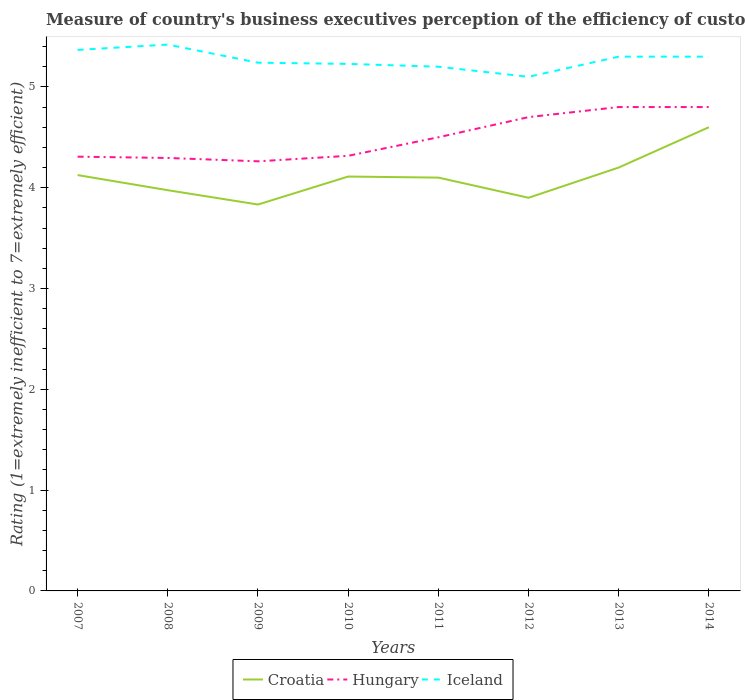How many different coloured lines are there?
Your answer should be compact. 3. Does the line corresponding to Croatia intersect with the line corresponding to Hungary?
Make the answer very short. No. Is the number of lines equal to the number of legend labels?
Offer a very short reply. Yes. Across all years, what is the maximum rating of the efficiency of customs procedure in Croatia?
Ensure brevity in your answer.  3.83. In which year was the rating of the efficiency of customs procedure in Croatia maximum?
Keep it short and to the point. 2009. What is the total rating of the efficiency of customs procedure in Hungary in the graph?
Provide a short and direct response. 0.03. What is the difference between the highest and the second highest rating of the efficiency of customs procedure in Iceland?
Your answer should be compact. 0.32. How many lines are there?
Ensure brevity in your answer.  3. Are the values on the major ticks of Y-axis written in scientific E-notation?
Offer a very short reply. No. Does the graph contain grids?
Make the answer very short. No. What is the title of the graph?
Keep it short and to the point. Measure of country's business executives perception of the efficiency of customs procedures. What is the label or title of the Y-axis?
Offer a terse response. Rating (1=extremely inefficient to 7=extremely efficient). What is the Rating (1=extremely inefficient to 7=extremely efficient) in Croatia in 2007?
Your response must be concise. 4.12. What is the Rating (1=extremely inefficient to 7=extremely efficient) of Hungary in 2007?
Ensure brevity in your answer.  4.31. What is the Rating (1=extremely inefficient to 7=extremely efficient) in Iceland in 2007?
Provide a succinct answer. 5.37. What is the Rating (1=extremely inefficient to 7=extremely efficient) of Croatia in 2008?
Your response must be concise. 3.98. What is the Rating (1=extremely inefficient to 7=extremely efficient) of Hungary in 2008?
Keep it short and to the point. 4.29. What is the Rating (1=extremely inefficient to 7=extremely efficient) in Iceland in 2008?
Your answer should be very brief. 5.42. What is the Rating (1=extremely inefficient to 7=extremely efficient) in Croatia in 2009?
Provide a short and direct response. 3.83. What is the Rating (1=extremely inefficient to 7=extremely efficient) of Hungary in 2009?
Provide a succinct answer. 4.26. What is the Rating (1=extremely inefficient to 7=extremely efficient) of Iceland in 2009?
Provide a succinct answer. 5.24. What is the Rating (1=extremely inefficient to 7=extremely efficient) of Croatia in 2010?
Provide a succinct answer. 4.11. What is the Rating (1=extremely inefficient to 7=extremely efficient) of Hungary in 2010?
Give a very brief answer. 4.32. What is the Rating (1=extremely inefficient to 7=extremely efficient) in Iceland in 2010?
Make the answer very short. 5.23. What is the Rating (1=extremely inefficient to 7=extremely efficient) of Croatia in 2011?
Your response must be concise. 4.1. What is the Rating (1=extremely inefficient to 7=extremely efficient) of Iceland in 2011?
Provide a succinct answer. 5.2. What is the Rating (1=extremely inefficient to 7=extremely efficient) of Croatia in 2012?
Provide a short and direct response. 3.9. What is the Rating (1=extremely inefficient to 7=extremely efficient) in Croatia in 2013?
Your answer should be very brief. 4.2. What is the Rating (1=extremely inefficient to 7=extremely efficient) of Croatia in 2014?
Provide a short and direct response. 4.6. What is the Rating (1=extremely inefficient to 7=extremely efficient) of Hungary in 2014?
Give a very brief answer. 4.8. Across all years, what is the maximum Rating (1=extremely inefficient to 7=extremely efficient) in Croatia?
Offer a terse response. 4.6. Across all years, what is the maximum Rating (1=extremely inefficient to 7=extremely efficient) in Iceland?
Ensure brevity in your answer.  5.42. Across all years, what is the minimum Rating (1=extremely inefficient to 7=extremely efficient) of Croatia?
Ensure brevity in your answer.  3.83. Across all years, what is the minimum Rating (1=extremely inefficient to 7=extremely efficient) in Hungary?
Provide a succinct answer. 4.26. Across all years, what is the minimum Rating (1=extremely inefficient to 7=extremely efficient) in Iceland?
Give a very brief answer. 5.1. What is the total Rating (1=extremely inefficient to 7=extremely efficient) of Croatia in the graph?
Your answer should be very brief. 32.84. What is the total Rating (1=extremely inefficient to 7=extremely efficient) of Hungary in the graph?
Offer a very short reply. 35.98. What is the total Rating (1=extremely inefficient to 7=extremely efficient) of Iceland in the graph?
Your response must be concise. 42.15. What is the difference between the Rating (1=extremely inefficient to 7=extremely efficient) in Hungary in 2007 and that in 2008?
Your response must be concise. 0.01. What is the difference between the Rating (1=extremely inefficient to 7=extremely efficient) in Iceland in 2007 and that in 2008?
Provide a short and direct response. -0.05. What is the difference between the Rating (1=extremely inefficient to 7=extremely efficient) in Croatia in 2007 and that in 2009?
Offer a very short reply. 0.29. What is the difference between the Rating (1=extremely inefficient to 7=extremely efficient) in Hungary in 2007 and that in 2009?
Your answer should be very brief. 0.05. What is the difference between the Rating (1=extremely inefficient to 7=extremely efficient) of Iceland in 2007 and that in 2009?
Keep it short and to the point. 0.13. What is the difference between the Rating (1=extremely inefficient to 7=extremely efficient) of Croatia in 2007 and that in 2010?
Keep it short and to the point. 0.01. What is the difference between the Rating (1=extremely inefficient to 7=extremely efficient) in Hungary in 2007 and that in 2010?
Your answer should be very brief. -0.01. What is the difference between the Rating (1=extremely inefficient to 7=extremely efficient) in Iceland in 2007 and that in 2010?
Give a very brief answer. 0.14. What is the difference between the Rating (1=extremely inefficient to 7=extremely efficient) of Croatia in 2007 and that in 2011?
Provide a short and direct response. 0.03. What is the difference between the Rating (1=extremely inefficient to 7=extremely efficient) of Hungary in 2007 and that in 2011?
Provide a short and direct response. -0.19. What is the difference between the Rating (1=extremely inefficient to 7=extremely efficient) of Croatia in 2007 and that in 2012?
Make the answer very short. 0.23. What is the difference between the Rating (1=extremely inefficient to 7=extremely efficient) of Hungary in 2007 and that in 2012?
Your response must be concise. -0.39. What is the difference between the Rating (1=extremely inefficient to 7=extremely efficient) of Iceland in 2007 and that in 2012?
Give a very brief answer. 0.27. What is the difference between the Rating (1=extremely inefficient to 7=extremely efficient) of Croatia in 2007 and that in 2013?
Keep it short and to the point. -0.07. What is the difference between the Rating (1=extremely inefficient to 7=extremely efficient) in Hungary in 2007 and that in 2013?
Your answer should be very brief. -0.49. What is the difference between the Rating (1=extremely inefficient to 7=extremely efficient) of Iceland in 2007 and that in 2013?
Offer a terse response. 0.07. What is the difference between the Rating (1=extremely inefficient to 7=extremely efficient) of Croatia in 2007 and that in 2014?
Provide a short and direct response. -0.47. What is the difference between the Rating (1=extremely inefficient to 7=extremely efficient) in Hungary in 2007 and that in 2014?
Offer a terse response. -0.49. What is the difference between the Rating (1=extremely inefficient to 7=extremely efficient) in Iceland in 2007 and that in 2014?
Provide a succinct answer. 0.07. What is the difference between the Rating (1=extremely inefficient to 7=extremely efficient) in Croatia in 2008 and that in 2009?
Your answer should be compact. 0.14. What is the difference between the Rating (1=extremely inefficient to 7=extremely efficient) of Hungary in 2008 and that in 2009?
Your response must be concise. 0.03. What is the difference between the Rating (1=extremely inefficient to 7=extremely efficient) in Iceland in 2008 and that in 2009?
Your response must be concise. 0.18. What is the difference between the Rating (1=extremely inefficient to 7=extremely efficient) of Croatia in 2008 and that in 2010?
Your answer should be very brief. -0.14. What is the difference between the Rating (1=extremely inefficient to 7=extremely efficient) of Hungary in 2008 and that in 2010?
Your answer should be compact. -0.02. What is the difference between the Rating (1=extremely inefficient to 7=extremely efficient) in Iceland in 2008 and that in 2010?
Your answer should be very brief. 0.19. What is the difference between the Rating (1=extremely inefficient to 7=extremely efficient) in Croatia in 2008 and that in 2011?
Make the answer very short. -0.12. What is the difference between the Rating (1=extremely inefficient to 7=extremely efficient) of Hungary in 2008 and that in 2011?
Your response must be concise. -0.21. What is the difference between the Rating (1=extremely inefficient to 7=extremely efficient) in Iceland in 2008 and that in 2011?
Give a very brief answer. 0.22. What is the difference between the Rating (1=extremely inefficient to 7=extremely efficient) of Croatia in 2008 and that in 2012?
Ensure brevity in your answer.  0.07. What is the difference between the Rating (1=extremely inefficient to 7=extremely efficient) in Hungary in 2008 and that in 2012?
Your response must be concise. -0.41. What is the difference between the Rating (1=extremely inefficient to 7=extremely efficient) of Iceland in 2008 and that in 2012?
Offer a terse response. 0.32. What is the difference between the Rating (1=extremely inefficient to 7=extremely efficient) of Croatia in 2008 and that in 2013?
Offer a terse response. -0.23. What is the difference between the Rating (1=extremely inefficient to 7=extremely efficient) in Hungary in 2008 and that in 2013?
Offer a terse response. -0.51. What is the difference between the Rating (1=extremely inefficient to 7=extremely efficient) in Iceland in 2008 and that in 2013?
Provide a succinct answer. 0.12. What is the difference between the Rating (1=extremely inefficient to 7=extremely efficient) in Croatia in 2008 and that in 2014?
Your answer should be very brief. -0.62. What is the difference between the Rating (1=extremely inefficient to 7=extremely efficient) in Hungary in 2008 and that in 2014?
Your answer should be very brief. -0.51. What is the difference between the Rating (1=extremely inefficient to 7=extremely efficient) in Iceland in 2008 and that in 2014?
Your answer should be very brief. 0.12. What is the difference between the Rating (1=extremely inefficient to 7=extremely efficient) of Croatia in 2009 and that in 2010?
Your answer should be compact. -0.28. What is the difference between the Rating (1=extremely inefficient to 7=extremely efficient) of Hungary in 2009 and that in 2010?
Keep it short and to the point. -0.05. What is the difference between the Rating (1=extremely inefficient to 7=extremely efficient) in Iceland in 2009 and that in 2010?
Give a very brief answer. 0.01. What is the difference between the Rating (1=extremely inefficient to 7=extremely efficient) in Croatia in 2009 and that in 2011?
Provide a succinct answer. -0.27. What is the difference between the Rating (1=extremely inefficient to 7=extremely efficient) in Hungary in 2009 and that in 2011?
Offer a very short reply. -0.24. What is the difference between the Rating (1=extremely inefficient to 7=extremely efficient) in Iceland in 2009 and that in 2011?
Provide a short and direct response. 0.04. What is the difference between the Rating (1=extremely inefficient to 7=extremely efficient) of Croatia in 2009 and that in 2012?
Offer a very short reply. -0.07. What is the difference between the Rating (1=extremely inefficient to 7=extremely efficient) of Hungary in 2009 and that in 2012?
Provide a short and direct response. -0.44. What is the difference between the Rating (1=extremely inefficient to 7=extremely efficient) of Iceland in 2009 and that in 2012?
Provide a succinct answer. 0.14. What is the difference between the Rating (1=extremely inefficient to 7=extremely efficient) in Croatia in 2009 and that in 2013?
Your answer should be compact. -0.37. What is the difference between the Rating (1=extremely inefficient to 7=extremely efficient) in Hungary in 2009 and that in 2013?
Make the answer very short. -0.54. What is the difference between the Rating (1=extremely inefficient to 7=extremely efficient) of Iceland in 2009 and that in 2013?
Ensure brevity in your answer.  -0.06. What is the difference between the Rating (1=extremely inefficient to 7=extremely efficient) in Croatia in 2009 and that in 2014?
Offer a terse response. -0.77. What is the difference between the Rating (1=extremely inefficient to 7=extremely efficient) in Hungary in 2009 and that in 2014?
Your answer should be compact. -0.54. What is the difference between the Rating (1=extremely inefficient to 7=extremely efficient) of Iceland in 2009 and that in 2014?
Provide a short and direct response. -0.06. What is the difference between the Rating (1=extremely inefficient to 7=extremely efficient) of Croatia in 2010 and that in 2011?
Offer a terse response. 0.01. What is the difference between the Rating (1=extremely inefficient to 7=extremely efficient) in Hungary in 2010 and that in 2011?
Your answer should be very brief. -0.18. What is the difference between the Rating (1=extremely inefficient to 7=extremely efficient) of Iceland in 2010 and that in 2011?
Provide a short and direct response. 0.03. What is the difference between the Rating (1=extremely inefficient to 7=extremely efficient) in Croatia in 2010 and that in 2012?
Provide a succinct answer. 0.21. What is the difference between the Rating (1=extremely inefficient to 7=extremely efficient) in Hungary in 2010 and that in 2012?
Ensure brevity in your answer.  -0.38. What is the difference between the Rating (1=extremely inefficient to 7=extremely efficient) in Iceland in 2010 and that in 2012?
Your response must be concise. 0.13. What is the difference between the Rating (1=extremely inefficient to 7=extremely efficient) of Croatia in 2010 and that in 2013?
Offer a very short reply. -0.09. What is the difference between the Rating (1=extremely inefficient to 7=extremely efficient) of Hungary in 2010 and that in 2013?
Give a very brief answer. -0.48. What is the difference between the Rating (1=extremely inefficient to 7=extremely efficient) in Iceland in 2010 and that in 2013?
Offer a very short reply. -0.07. What is the difference between the Rating (1=extremely inefficient to 7=extremely efficient) in Croatia in 2010 and that in 2014?
Your response must be concise. -0.49. What is the difference between the Rating (1=extremely inefficient to 7=extremely efficient) in Hungary in 2010 and that in 2014?
Provide a succinct answer. -0.48. What is the difference between the Rating (1=extremely inefficient to 7=extremely efficient) of Iceland in 2010 and that in 2014?
Your answer should be very brief. -0.07. What is the difference between the Rating (1=extremely inefficient to 7=extremely efficient) in Hungary in 2011 and that in 2012?
Ensure brevity in your answer.  -0.2. What is the difference between the Rating (1=extremely inefficient to 7=extremely efficient) of Iceland in 2011 and that in 2012?
Keep it short and to the point. 0.1. What is the difference between the Rating (1=extremely inefficient to 7=extremely efficient) of Hungary in 2011 and that in 2013?
Ensure brevity in your answer.  -0.3. What is the difference between the Rating (1=extremely inefficient to 7=extremely efficient) in Iceland in 2011 and that in 2013?
Offer a very short reply. -0.1. What is the difference between the Rating (1=extremely inefficient to 7=extremely efficient) of Iceland in 2012 and that in 2013?
Offer a terse response. -0.2. What is the difference between the Rating (1=extremely inefficient to 7=extremely efficient) in Croatia in 2012 and that in 2014?
Offer a very short reply. -0.7. What is the difference between the Rating (1=extremely inefficient to 7=extremely efficient) in Hungary in 2012 and that in 2014?
Provide a succinct answer. -0.1. What is the difference between the Rating (1=extremely inefficient to 7=extremely efficient) of Iceland in 2013 and that in 2014?
Your response must be concise. 0. What is the difference between the Rating (1=extremely inefficient to 7=extremely efficient) of Croatia in 2007 and the Rating (1=extremely inefficient to 7=extremely efficient) of Hungary in 2008?
Provide a succinct answer. -0.17. What is the difference between the Rating (1=extremely inefficient to 7=extremely efficient) of Croatia in 2007 and the Rating (1=extremely inefficient to 7=extremely efficient) of Iceland in 2008?
Provide a succinct answer. -1.29. What is the difference between the Rating (1=extremely inefficient to 7=extremely efficient) of Hungary in 2007 and the Rating (1=extremely inefficient to 7=extremely efficient) of Iceland in 2008?
Keep it short and to the point. -1.11. What is the difference between the Rating (1=extremely inefficient to 7=extremely efficient) of Croatia in 2007 and the Rating (1=extremely inefficient to 7=extremely efficient) of Hungary in 2009?
Make the answer very short. -0.14. What is the difference between the Rating (1=extremely inefficient to 7=extremely efficient) in Croatia in 2007 and the Rating (1=extremely inefficient to 7=extremely efficient) in Iceland in 2009?
Your answer should be very brief. -1.11. What is the difference between the Rating (1=extremely inefficient to 7=extremely efficient) of Hungary in 2007 and the Rating (1=extremely inefficient to 7=extremely efficient) of Iceland in 2009?
Your answer should be compact. -0.93. What is the difference between the Rating (1=extremely inefficient to 7=extremely efficient) of Croatia in 2007 and the Rating (1=extremely inefficient to 7=extremely efficient) of Hungary in 2010?
Provide a short and direct response. -0.19. What is the difference between the Rating (1=extremely inefficient to 7=extremely efficient) of Croatia in 2007 and the Rating (1=extremely inefficient to 7=extremely efficient) of Iceland in 2010?
Provide a short and direct response. -1.1. What is the difference between the Rating (1=extremely inefficient to 7=extremely efficient) in Hungary in 2007 and the Rating (1=extremely inefficient to 7=extremely efficient) in Iceland in 2010?
Your response must be concise. -0.92. What is the difference between the Rating (1=extremely inefficient to 7=extremely efficient) of Croatia in 2007 and the Rating (1=extremely inefficient to 7=extremely efficient) of Hungary in 2011?
Your answer should be compact. -0.38. What is the difference between the Rating (1=extremely inefficient to 7=extremely efficient) in Croatia in 2007 and the Rating (1=extremely inefficient to 7=extremely efficient) in Iceland in 2011?
Give a very brief answer. -1.07. What is the difference between the Rating (1=extremely inefficient to 7=extremely efficient) in Hungary in 2007 and the Rating (1=extremely inefficient to 7=extremely efficient) in Iceland in 2011?
Your response must be concise. -0.89. What is the difference between the Rating (1=extremely inefficient to 7=extremely efficient) of Croatia in 2007 and the Rating (1=extremely inefficient to 7=extremely efficient) of Hungary in 2012?
Offer a very short reply. -0.57. What is the difference between the Rating (1=extremely inefficient to 7=extremely efficient) of Croatia in 2007 and the Rating (1=extremely inefficient to 7=extremely efficient) of Iceland in 2012?
Give a very brief answer. -0.97. What is the difference between the Rating (1=extremely inefficient to 7=extremely efficient) of Hungary in 2007 and the Rating (1=extremely inefficient to 7=extremely efficient) of Iceland in 2012?
Offer a terse response. -0.79. What is the difference between the Rating (1=extremely inefficient to 7=extremely efficient) of Croatia in 2007 and the Rating (1=extremely inefficient to 7=extremely efficient) of Hungary in 2013?
Make the answer very short. -0.68. What is the difference between the Rating (1=extremely inefficient to 7=extremely efficient) in Croatia in 2007 and the Rating (1=extremely inefficient to 7=extremely efficient) in Iceland in 2013?
Offer a very short reply. -1.18. What is the difference between the Rating (1=extremely inefficient to 7=extremely efficient) of Hungary in 2007 and the Rating (1=extremely inefficient to 7=extremely efficient) of Iceland in 2013?
Make the answer very short. -0.99. What is the difference between the Rating (1=extremely inefficient to 7=extremely efficient) of Croatia in 2007 and the Rating (1=extremely inefficient to 7=extremely efficient) of Hungary in 2014?
Keep it short and to the point. -0.68. What is the difference between the Rating (1=extremely inefficient to 7=extremely efficient) in Croatia in 2007 and the Rating (1=extremely inefficient to 7=extremely efficient) in Iceland in 2014?
Offer a terse response. -1.18. What is the difference between the Rating (1=extremely inefficient to 7=extremely efficient) in Hungary in 2007 and the Rating (1=extremely inefficient to 7=extremely efficient) in Iceland in 2014?
Make the answer very short. -0.99. What is the difference between the Rating (1=extremely inefficient to 7=extremely efficient) in Croatia in 2008 and the Rating (1=extremely inefficient to 7=extremely efficient) in Hungary in 2009?
Give a very brief answer. -0.29. What is the difference between the Rating (1=extremely inefficient to 7=extremely efficient) of Croatia in 2008 and the Rating (1=extremely inefficient to 7=extremely efficient) of Iceland in 2009?
Ensure brevity in your answer.  -1.26. What is the difference between the Rating (1=extremely inefficient to 7=extremely efficient) of Hungary in 2008 and the Rating (1=extremely inefficient to 7=extremely efficient) of Iceland in 2009?
Keep it short and to the point. -0.94. What is the difference between the Rating (1=extremely inefficient to 7=extremely efficient) in Croatia in 2008 and the Rating (1=extremely inefficient to 7=extremely efficient) in Hungary in 2010?
Your answer should be compact. -0.34. What is the difference between the Rating (1=extremely inefficient to 7=extremely efficient) of Croatia in 2008 and the Rating (1=extremely inefficient to 7=extremely efficient) of Iceland in 2010?
Keep it short and to the point. -1.25. What is the difference between the Rating (1=extremely inefficient to 7=extremely efficient) of Hungary in 2008 and the Rating (1=extremely inefficient to 7=extremely efficient) of Iceland in 2010?
Provide a short and direct response. -0.93. What is the difference between the Rating (1=extremely inefficient to 7=extremely efficient) in Croatia in 2008 and the Rating (1=extremely inefficient to 7=extremely efficient) in Hungary in 2011?
Your answer should be compact. -0.53. What is the difference between the Rating (1=extremely inefficient to 7=extremely efficient) of Croatia in 2008 and the Rating (1=extremely inefficient to 7=extremely efficient) of Iceland in 2011?
Give a very brief answer. -1.23. What is the difference between the Rating (1=extremely inefficient to 7=extremely efficient) in Hungary in 2008 and the Rating (1=extremely inefficient to 7=extremely efficient) in Iceland in 2011?
Provide a short and direct response. -0.91. What is the difference between the Rating (1=extremely inefficient to 7=extremely efficient) in Croatia in 2008 and the Rating (1=extremely inefficient to 7=extremely efficient) in Hungary in 2012?
Give a very brief answer. -0.72. What is the difference between the Rating (1=extremely inefficient to 7=extremely efficient) of Croatia in 2008 and the Rating (1=extremely inefficient to 7=extremely efficient) of Iceland in 2012?
Your answer should be compact. -1.12. What is the difference between the Rating (1=extremely inefficient to 7=extremely efficient) of Hungary in 2008 and the Rating (1=extremely inefficient to 7=extremely efficient) of Iceland in 2012?
Offer a very short reply. -0.81. What is the difference between the Rating (1=extremely inefficient to 7=extremely efficient) of Croatia in 2008 and the Rating (1=extremely inefficient to 7=extremely efficient) of Hungary in 2013?
Provide a succinct answer. -0.82. What is the difference between the Rating (1=extremely inefficient to 7=extremely efficient) of Croatia in 2008 and the Rating (1=extremely inefficient to 7=extremely efficient) of Iceland in 2013?
Ensure brevity in your answer.  -1.32. What is the difference between the Rating (1=extremely inefficient to 7=extremely efficient) in Hungary in 2008 and the Rating (1=extremely inefficient to 7=extremely efficient) in Iceland in 2013?
Offer a very short reply. -1.01. What is the difference between the Rating (1=extremely inefficient to 7=extremely efficient) of Croatia in 2008 and the Rating (1=extremely inefficient to 7=extremely efficient) of Hungary in 2014?
Your answer should be very brief. -0.82. What is the difference between the Rating (1=extremely inefficient to 7=extremely efficient) of Croatia in 2008 and the Rating (1=extremely inefficient to 7=extremely efficient) of Iceland in 2014?
Keep it short and to the point. -1.32. What is the difference between the Rating (1=extremely inefficient to 7=extremely efficient) of Hungary in 2008 and the Rating (1=extremely inefficient to 7=extremely efficient) of Iceland in 2014?
Offer a very short reply. -1.01. What is the difference between the Rating (1=extremely inefficient to 7=extremely efficient) of Croatia in 2009 and the Rating (1=extremely inefficient to 7=extremely efficient) of Hungary in 2010?
Keep it short and to the point. -0.48. What is the difference between the Rating (1=extremely inefficient to 7=extremely efficient) of Croatia in 2009 and the Rating (1=extremely inefficient to 7=extremely efficient) of Iceland in 2010?
Give a very brief answer. -1.39. What is the difference between the Rating (1=extremely inefficient to 7=extremely efficient) of Hungary in 2009 and the Rating (1=extremely inefficient to 7=extremely efficient) of Iceland in 2010?
Your response must be concise. -0.97. What is the difference between the Rating (1=extremely inefficient to 7=extremely efficient) in Croatia in 2009 and the Rating (1=extremely inefficient to 7=extremely efficient) in Hungary in 2011?
Give a very brief answer. -0.67. What is the difference between the Rating (1=extremely inefficient to 7=extremely efficient) of Croatia in 2009 and the Rating (1=extremely inefficient to 7=extremely efficient) of Iceland in 2011?
Your answer should be compact. -1.37. What is the difference between the Rating (1=extremely inefficient to 7=extremely efficient) of Hungary in 2009 and the Rating (1=extremely inefficient to 7=extremely efficient) of Iceland in 2011?
Offer a terse response. -0.94. What is the difference between the Rating (1=extremely inefficient to 7=extremely efficient) in Croatia in 2009 and the Rating (1=extremely inefficient to 7=extremely efficient) in Hungary in 2012?
Give a very brief answer. -0.87. What is the difference between the Rating (1=extremely inefficient to 7=extremely efficient) of Croatia in 2009 and the Rating (1=extremely inefficient to 7=extremely efficient) of Iceland in 2012?
Ensure brevity in your answer.  -1.27. What is the difference between the Rating (1=extremely inefficient to 7=extremely efficient) in Hungary in 2009 and the Rating (1=extremely inefficient to 7=extremely efficient) in Iceland in 2012?
Provide a short and direct response. -0.84. What is the difference between the Rating (1=extremely inefficient to 7=extremely efficient) in Croatia in 2009 and the Rating (1=extremely inefficient to 7=extremely efficient) in Hungary in 2013?
Give a very brief answer. -0.97. What is the difference between the Rating (1=extremely inefficient to 7=extremely efficient) of Croatia in 2009 and the Rating (1=extremely inefficient to 7=extremely efficient) of Iceland in 2013?
Provide a short and direct response. -1.47. What is the difference between the Rating (1=extremely inefficient to 7=extremely efficient) in Hungary in 2009 and the Rating (1=extremely inefficient to 7=extremely efficient) in Iceland in 2013?
Give a very brief answer. -1.04. What is the difference between the Rating (1=extremely inefficient to 7=extremely efficient) in Croatia in 2009 and the Rating (1=extremely inefficient to 7=extremely efficient) in Hungary in 2014?
Offer a very short reply. -0.97. What is the difference between the Rating (1=extremely inefficient to 7=extremely efficient) in Croatia in 2009 and the Rating (1=extremely inefficient to 7=extremely efficient) in Iceland in 2014?
Your response must be concise. -1.47. What is the difference between the Rating (1=extremely inefficient to 7=extremely efficient) in Hungary in 2009 and the Rating (1=extremely inefficient to 7=extremely efficient) in Iceland in 2014?
Your answer should be compact. -1.04. What is the difference between the Rating (1=extremely inefficient to 7=extremely efficient) in Croatia in 2010 and the Rating (1=extremely inefficient to 7=extremely efficient) in Hungary in 2011?
Your answer should be compact. -0.39. What is the difference between the Rating (1=extremely inefficient to 7=extremely efficient) of Croatia in 2010 and the Rating (1=extremely inefficient to 7=extremely efficient) of Iceland in 2011?
Give a very brief answer. -1.09. What is the difference between the Rating (1=extremely inefficient to 7=extremely efficient) of Hungary in 2010 and the Rating (1=extremely inefficient to 7=extremely efficient) of Iceland in 2011?
Your answer should be very brief. -0.88. What is the difference between the Rating (1=extremely inefficient to 7=extremely efficient) in Croatia in 2010 and the Rating (1=extremely inefficient to 7=extremely efficient) in Hungary in 2012?
Provide a short and direct response. -0.59. What is the difference between the Rating (1=extremely inefficient to 7=extremely efficient) in Croatia in 2010 and the Rating (1=extremely inefficient to 7=extremely efficient) in Iceland in 2012?
Keep it short and to the point. -0.99. What is the difference between the Rating (1=extremely inefficient to 7=extremely efficient) in Hungary in 2010 and the Rating (1=extremely inefficient to 7=extremely efficient) in Iceland in 2012?
Provide a short and direct response. -0.78. What is the difference between the Rating (1=extremely inefficient to 7=extremely efficient) in Croatia in 2010 and the Rating (1=extremely inefficient to 7=extremely efficient) in Hungary in 2013?
Provide a succinct answer. -0.69. What is the difference between the Rating (1=extremely inefficient to 7=extremely efficient) in Croatia in 2010 and the Rating (1=extremely inefficient to 7=extremely efficient) in Iceland in 2013?
Provide a short and direct response. -1.19. What is the difference between the Rating (1=extremely inefficient to 7=extremely efficient) in Hungary in 2010 and the Rating (1=extremely inefficient to 7=extremely efficient) in Iceland in 2013?
Provide a succinct answer. -0.98. What is the difference between the Rating (1=extremely inefficient to 7=extremely efficient) in Croatia in 2010 and the Rating (1=extremely inefficient to 7=extremely efficient) in Hungary in 2014?
Offer a very short reply. -0.69. What is the difference between the Rating (1=extremely inefficient to 7=extremely efficient) in Croatia in 2010 and the Rating (1=extremely inefficient to 7=extremely efficient) in Iceland in 2014?
Offer a terse response. -1.19. What is the difference between the Rating (1=extremely inefficient to 7=extremely efficient) of Hungary in 2010 and the Rating (1=extremely inefficient to 7=extremely efficient) of Iceland in 2014?
Provide a succinct answer. -0.98. What is the difference between the Rating (1=extremely inefficient to 7=extremely efficient) of Croatia in 2011 and the Rating (1=extremely inefficient to 7=extremely efficient) of Hungary in 2012?
Offer a terse response. -0.6. What is the difference between the Rating (1=extremely inefficient to 7=extremely efficient) in Croatia in 2011 and the Rating (1=extremely inefficient to 7=extremely efficient) in Iceland in 2012?
Keep it short and to the point. -1. What is the difference between the Rating (1=extremely inefficient to 7=extremely efficient) of Hungary in 2011 and the Rating (1=extremely inefficient to 7=extremely efficient) of Iceland in 2013?
Provide a short and direct response. -0.8. What is the difference between the Rating (1=extremely inefficient to 7=extremely efficient) in Croatia in 2011 and the Rating (1=extremely inefficient to 7=extremely efficient) in Hungary in 2014?
Give a very brief answer. -0.7. What is the difference between the Rating (1=extremely inefficient to 7=extremely efficient) of Hungary in 2011 and the Rating (1=extremely inefficient to 7=extremely efficient) of Iceland in 2014?
Your answer should be compact. -0.8. What is the difference between the Rating (1=extremely inefficient to 7=extremely efficient) in Croatia in 2012 and the Rating (1=extremely inefficient to 7=extremely efficient) in Hungary in 2013?
Offer a very short reply. -0.9. What is the difference between the Rating (1=extremely inefficient to 7=extremely efficient) in Croatia in 2012 and the Rating (1=extremely inefficient to 7=extremely efficient) in Iceland in 2014?
Ensure brevity in your answer.  -1.4. What is the difference between the Rating (1=extremely inefficient to 7=extremely efficient) in Hungary in 2012 and the Rating (1=extremely inefficient to 7=extremely efficient) in Iceland in 2014?
Your response must be concise. -0.6. What is the difference between the Rating (1=extremely inefficient to 7=extremely efficient) in Croatia in 2013 and the Rating (1=extremely inefficient to 7=extremely efficient) in Hungary in 2014?
Offer a very short reply. -0.6. What is the difference between the Rating (1=extremely inefficient to 7=extremely efficient) in Croatia in 2013 and the Rating (1=extremely inefficient to 7=extremely efficient) in Iceland in 2014?
Provide a succinct answer. -1.1. What is the difference between the Rating (1=extremely inefficient to 7=extremely efficient) in Hungary in 2013 and the Rating (1=extremely inefficient to 7=extremely efficient) in Iceland in 2014?
Provide a short and direct response. -0.5. What is the average Rating (1=extremely inefficient to 7=extremely efficient) in Croatia per year?
Offer a very short reply. 4.11. What is the average Rating (1=extremely inefficient to 7=extremely efficient) of Hungary per year?
Ensure brevity in your answer.  4.5. What is the average Rating (1=extremely inefficient to 7=extremely efficient) of Iceland per year?
Offer a terse response. 5.27. In the year 2007, what is the difference between the Rating (1=extremely inefficient to 7=extremely efficient) of Croatia and Rating (1=extremely inefficient to 7=extremely efficient) of Hungary?
Offer a very short reply. -0.18. In the year 2007, what is the difference between the Rating (1=extremely inefficient to 7=extremely efficient) in Croatia and Rating (1=extremely inefficient to 7=extremely efficient) in Iceland?
Keep it short and to the point. -1.24. In the year 2007, what is the difference between the Rating (1=extremely inefficient to 7=extremely efficient) of Hungary and Rating (1=extremely inefficient to 7=extremely efficient) of Iceland?
Give a very brief answer. -1.06. In the year 2008, what is the difference between the Rating (1=extremely inefficient to 7=extremely efficient) in Croatia and Rating (1=extremely inefficient to 7=extremely efficient) in Hungary?
Offer a terse response. -0.32. In the year 2008, what is the difference between the Rating (1=extremely inefficient to 7=extremely efficient) of Croatia and Rating (1=extremely inefficient to 7=extremely efficient) of Iceland?
Ensure brevity in your answer.  -1.44. In the year 2008, what is the difference between the Rating (1=extremely inefficient to 7=extremely efficient) of Hungary and Rating (1=extremely inefficient to 7=extremely efficient) of Iceland?
Keep it short and to the point. -1.12. In the year 2009, what is the difference between the Rating (1=extremely inefficient to 7=extremely efficient) of Croatia and Rating (1=extremely inefficient to 7=extremely efficient) of Hungary?
Give a very brief answer. -0.43. In the year 2009, what is the difference between the Rating (1=extremely inefficient to 7=extremely efficient) in Croatia and Rating (1=extremely inefficient to 7=extremely efficient) in Iceland?
Your response must be concise. -1.41. In the year 2009, what is the difference between the Rating (1=extremely inefficient to 7=extremely efficient) of Hungary and Rating (1=extremely inefficient to 7=extremely efficient) of Iceland?
Provide a short and direct response. -0.98. In the year 2010, what is the difference between the Rating (1=extremely inefficient to 7=extremely efficient) in Croatia and Rating (1=extremely inefficient to 7=extremely efficient) in Hungary?
Offer a very short reply. -0.21. In the year 2010, what is the difference between the Rating (1=extremely inefficient to 7=extremely efficient) of Croatia and Rating (1=extremely inefficient to 7=extremely efficient) of Iceland?
Provide a short and direct response. -1.12. In the year 2010, what is the difference between the Rating (1=extremely inefficient to 7=extremely efficient) of Hungary and Rating (1=extremely inefficient to 7=extremely efficient) of Iceland?
Offer a terse response. -0.91. In the year 2011, what is the difference between the Rating (1=extremely inefficient to 7=extremely efficient) in Hungary and Rating (1=extremely inefficient to 7=extremely efficient) in Iceland?
Provide a short and direct response. -0.7. In the year 2012, what is the difference between the Rating (1=extremely inefficient to 7=extremely efficient) in Croatia and Rating (1=extremely inefficient to 7=extremely efficient) in Hungary?
Offer a very short reply. -0.8. In the year 2012, what is the difference between the Rating (1=extremely inefficient to 7=extremely efficient) in Croatia and Rating (1=extremely inefficient to 7=extremely efficient) in Iceland?
Make the answer very short. -1.2. In the year 2013, what is the difference between the Rating (1=extremely inefficient to 7=extremely efficient) in Croatia and Rating (1=extremely inefficient to 7=extremely efficient) in Iceland?
Ensure brevity in your answer.  -1.1. What is the ratio of the Rating (1=extremely inefficient to 7=extremely efficient) in Croatia in 2007 to that in 2008?
Give a very brief answer. 1.04. What is the ratio of the Rating (1=extremely inefficient to 7=extremely efficient) of Hungary in 2007 to that in 2008?
Provide a short and direct response. 1. What is the ratio of the Rating (1=extremely inefficient to 7=extremely efficient) in Iceland in 2007 to that in 2008?
Your response must be concise. 0.99. What is the ratio of the Rating (1=extremely inefficient to 7=extremely efficient) of Croatia in 2007 to that in 2009?
Your answer should be compact. 1.08. What is the ratio of the Rating (1=extremely inefficient to 7=extremely efficient) of Hungary in 2007 to that in 2009?
Ensure brevity in your answer.  1.01. What is the ratio of the Rating (1=extremely inefficient to 7=extremely efficient) of Iceland in 2007 to that in 2009?
Offer a terse response. 1.02. What is the ratio of the Rating (1=extremely inefficient to 7=extremely efficient) of Croatia in 2007 to that in 2010?
Provide a succinct answer. 1. What is the ratio of the Rating (1=extremely inefficient to 7=extremely efficient) of Hungary in 2007 to that in 2010?
Your response must be concise. 1. What is the ratio of the Rating (1=extremely inefficient to 7=extremely efficient) in Iceland in 2007 to that in 2010?
Give a very brief answer. 1.03. What is the ratio of the Rating (1=extremely inefficient to 7=extremely efficient) of Croatia in 2007 to that in 2011?
Offer a terse response. 1.01. What is the ratio of the Rating (1=extremely inefficient to 7=extremely efficient) in Hungary in 2007 to that in 2011?
Keep it short and to the point. 0.96. What is the ratio of the Rating (1=extremely inefficient to 7=extremely efficient) of Iceland in 2007 to that in 2011?
Your response must be concise. 1.03. What is the ratio of the Rating (1=extremely inefficient to 7=extremely efficient) of Croatia in 2007 to that in 2012?
Your answer should be very brief. 1.06. What is the ratio of the Rating (1=extremely inefficient to 7=extremely efficient) in Hungary in 2007 to that in 2012?
Keep it short and to the point. 0.92. What is the ratio of the Rating (1=extremely inefficient to 7=extremely efficient) of Iceland in 2007 to that in 2012?
Your response must be concise. 1.05. What is the ratio of the Rating (1=extremely inefficient to 7=extremely efficient) in Croatia in 2007 to that in 2013?
Ensure brevity in your answer.  0.98. What is the ratio of the Rating (1=extremely inefficient to 7=extremely efficient) of Hungary in 2007 to that in 2013?
Provide a succinct answer. 0.9. What is the ratio of the Rating (1=extremely inefficient to 7=extremely efficient) in Iceland in 2007 to that in 2013?
Give a very brief answer. 1.01. What is the ratio of the Rating (1=extremely inefficient to 7=extremely efficient) of Croatia in 2007 to that in 2014?
Your response must be concise. 0.9. What is the ratio of the Rating (1=extremely inefficient to 7=extremely efficient) of Hungary in 2007 to that in 2014?
Your answer should be very brief. 0.9. What is the ratio of the Rating (1=extremely inefficient to 7=extremely efficient) in Iceland in 2007 to that in 2014?
Ensure brevity in your answer.  1.01. What is the ratio of the Rating (1=extremely inefficient to 7=extremely efficient) in Croatia in 2008 to that in 2009?
Your answer should be very brief. 1.04. What is the ratio of the Rating (1=extremely inefficient to 7=extremely efficient) of Iceland in 2008 to that in 2009?
Your answer should be very brief. 1.03. What is the ratio of the Rating (1=extremely inefficient to 7=extremely efficient) in Croatia in 2008 to that in 2010?
Ensure brevity in your answer.  0.97. What is the ratio of the Rating (1=extremely inefficient to 7=extremely efficient) in Hungary in 2008 to that in 2010?
Your answer should be very brief. 1. What is the ratio of the Rating (1=extremely inefficient to 7=extremely efficient) in Iceland in 2008 to that in 2010?
Offer a very short reply. 1.04. What is the ratio of the Rating (1=extremely inefficient to 7=extremely efficient) of Croatia in 2008 to that in 2011?
Offer a terse response. 0.97. What is the ratio of the Rating (1=extremely inefficient to 7=extremely efficient) in Hungary in 2008 to that in 2011?
Your answer should be very brief. 0.95. What is the ratio of the Rating (1=extremely inefficient to 7=extremely efficient) in Iceland in 2008 to that in 2011?
Give a very brief answer. 1.04. What is the ratio of the Rating (1=extremely inefficient to 7=extremely efficient) of Croatia in 2008 to that in 2012?
Keep it short and to the point. 1.02. What is the ratio of the Rating (1=extremely inefficient to 7=extremely efficient) of Hungary in 2008 to that in 2012?
Provide a short and direct response. 0.91. What is the ratio of the Rating (1=extremely inefficient to 7=extremely efficient) of Iceland in 2008 to that in 2012?
Make the answer very short. 1.06. What is the ratio of the Rating (1=extremely inefficient to 7=extremely efficient) of Croatia in 2008 to that in 2013?
Offer a terse response. 0.95. What is the ratio of the Rating (1=extremely inefficient to 7=extremely efficient) in Hungary in 2008 to that in 2013?
Your response must be concise. 0.89. What is the ratio of the Rating (1=extremely inefficient to 7=extremely efficient) of Iceland in 2008 to that in 2013?
Your answer should be very brief. 1.02. What is the ratio of the Rating (1=extremely inefficient to 7=extremely efficient) of Croatia in 2008 to that in 2014?
Your response must be concise. 0.86. What is the ratio of the Rating (1=extremely inefficient to 7=extremely efficient) in Hungary in 2008 to that in 2014?
Make the answer very short. 0.89. What is the ratio of the Rating (1=extremely inefficient to 7=extremely efficient) of Iceland in 2008 to that in 2014?
Offer a terse response. 1.02. What is the ratio of the Rating (1=extremely inefficient to 7=extremely efficient) of Croatia in 2009 to that in 2010?
Give a very brief answer. 0.93. What is the ratio of the Rating (1=extremely inefficient to 7=extremely efficient) in Hungary in 2009 to that in 2010?
Your response must be concise. 0.99. What is the ratio of the Rating (1=extremely inefficient to 7=extremely efficient) in Iceland in 2009 to that in 2010?
Offer a very short reply. 1. What is the ratio of the Rating (1=extremely inefficient to 7=extremely efficient) of Croatia in 2009 to that in 2011?
Make the answer very short. 0.93. What is the ratio of the Rating (1=extremely inefficient to 7=extremely efficient) of Hungary in 2009 to that in 2011?
Offer a very short reply. 0.95. What is the ratio of the Rating (1=extremely inefficient to 7=extremely efficient) of Iceland in 2009 to that in 2011?
Your response must be concise. 1.01. What is the ratio of the Rating (1=extremely inefficient to 7=extremely efficient) in Croatia in 2009 to that in 2012?
Your response must be concise. 0.98. What is the ratio of the Rating (1=extremely inefficient to 7=extremely efficient) in Hungary in 2009 to that in 2012?
Provide a short and direct response. 0.91. What is the ratio of the Rating (1=extremely inefficient to 7=extremely efficient) of Iceland in 2009 to that in 2012?
Offer a terse response. 1.03. What is the ratio of the Rating (1=extremely inefficient to 7=extremely efficient) of Croatia in 2009 to that in 2013?
Your answer should be compact. 0.91. What is the ratio of the Rating (1=extremely inefficient to 7=extremely efficient) in Hungary in 2009 to that in 2013?
Offer a very short reply. 0.89. What is the ratio of the Rating (1=extremely inefficient to 7=extremely efficient) of Iceland in 2009 to that in 2013?
Offer a very short reply. 0.99. What is the ratio of the Rating (1=extremely inefficient to 7=extremely efficient) of Hungary in 2009 to that in 2014?
Your answer should be compact. 0.89. What is the ratio of the Rating (1=extremely inefficient to 7=extremely efficient) of Iceland in 2009 to that in 2014?
Provide a short and direct response. 0.99. What is the ratio of the Rating (1=extremely inefficient to 7=extremely efficient) in Croatia in 2010 to that in 2011?
Offer a very short reply. 1. What is the ratio of the Rating (1=extremely inefficient to 7=extremely efficient) of Hungary in 2010 to that in 2011?
Offer a very short reply. 0.96. What is the ratio of the Rating (1=extremely inefficient to 7=extremely efficient) in Iceland in 2010 to that in 2011?
Your response must be concise. 1.01. What is the ratio of the Rating (1=extremely inefficient to 7=extremely efficient) of Croatia in 2010 to that in 2012?
Your response must be concise. 1.05. What is the ratio of the Rating (1=extremely inefficient to 7=extremely efficient) of Hungary in 2010 to that in 2012?
Keep it short and to the point. 0.92. What is the ratio of the Rating (1=extremely inefficient to 7=extremely efficient) in Iceland in 2010 to that in 2012?
Offer a terse response. 1.03. What is the ratio of the Rating (1=extremely inefficient to 7=extremely efficient) in Croatia in 2010 to that in 2013?
Your answer should be compact. 0.98. What is the ratio of the Rating (1=extremely inefficient to 7=extremely efficient) of Hungary in 2010 to that in 2013?
Provide a short and direct response. 0.9. What is the ratio of the Rating (1=extremely inefficient to 7=extremely efficient) in Iceland in 2010 to that in 2013?
Offer a terse response. 0.99. What is the ratio of the Rating (1=extremely inefficient to 7=extremely efficient) of Croatia in 2010 to that in 2014?
Keep it short and to the point. 0.89. What is the ratio of the Rating (1=extremely inefficient to 7=extremely efficient) of Hungary in 2010 to that in 2014?
Your response must be concise. 0.9. What is the ratio of the Rating (1=extremely inefficient to 7=extremely efficient) in Iceland in 2010 to that in 2014?
Keep it short and to the point. 0.99. What is the ratio of the Rating (1=extremely inefficient to 7=extremely efficient) of Croatia in 2011 to that in 2012?
Offer a very short reply. 1.05. What is the ratio of the Rating (1=extremely inefficient to 7=extremely efficient) in Hungary in 2011 to that in 2012?
Provide a short and direct response. 0.96. What is the ratio of the Rating (1=extremely inefficient to 7=extremely efficient) of Iceland in 2011 to that in 2012?
Keep it short and to the point. 1.02. What is the ratio of the Rating (1=extremely inefficient to 7=extremely efficient) of Croatia in 2011 to that in 2013?
Give a very brief answer. 0.98. What is the ratio of the Rating (1=extremely inefficient to 7=extremely efficient) of Hungary in 2011 to that in 2013?
Your answer should be compact. 0.94. What is the ratio of the Rating (1=extremely inefficient to 7=extremely efficient) of Iceland in 2011 to that in 2013?
Provide a short and direct response. 0.98. What is the ratio of the Rating (1=extremely inefficient to 7=extremely efficient) in Croatia in 2011 to that in 2014?
Your response must be concise. 0.89. What is the ratio of the Rating (1=extremely inefficient to 7=extremely efficient) of Iceland in 2011 to that in 2014?
Make the answer very short. 0.98. What is the ratio of the Rating (1=extremely inefficient to 7=extremely efficient) in Croatia in 2012 to that in 2013?
Your response must be concise. 0.93. What is the ratio of the Rating (1=extremely inefficient to 7=extremely efficient) in Hungary in 2012 to that in 2013?
Give a very brief answer. 0.98. What is the ratio of the Rating (1=extremely inefficient to 7=extremely efficient) in Iceland in 2012 to that in 2013?
Offer a terse response. 0.96. What is the ratio of the Rating (1=extremely inefficient to 7=extremely efficient) in Croatia in 2012 to that in 2014?
Offer a very short reply. 0.85. What is the ratio of the Rating (1=extremely inefficient to 7=extremely efficient) of Hungary in 2012 to that in 2014?
Your answer should be compact. 0.98. What is the ratio of the Rating (1=extremely inefficient to 7=extremely efficient) of Iceland in 2012 to that in 2014?
Your answer should be very brief. 0.96. What is the ratio of the Rating (1=extremely inefficient to 7=extremely efficient) in Hungary in 2013 to that in 2014?
Your response must be concise. 1. What is the difference between the highest and the second highest Rating (1=extremely inefficient to 7=extremely efficient) of Croatia?
Keep it short and to the point. 0.4. What is the difference between the highest and the second highest Rating (1=extremely inefficient to 7=extremely efficient) in Iceland?
Offer a terse response. 0.05. What is the difference between the highest and the lowest Rating (1=extremely inefficient to 7=extremely efficient) in Croatia?
Give a very brief answer. 0.77. What is the difference between the highest and the lowest Rating (1=extremely inefficient to 7=extremely efficient) of Hungary?
Provide a succinct answer. 0.54. What is the difference between the highest and the lowest Rating (1=extremely inefficient to 7=extremely efficient) of Iceland?
Provide a succinct answer. 0.32. 